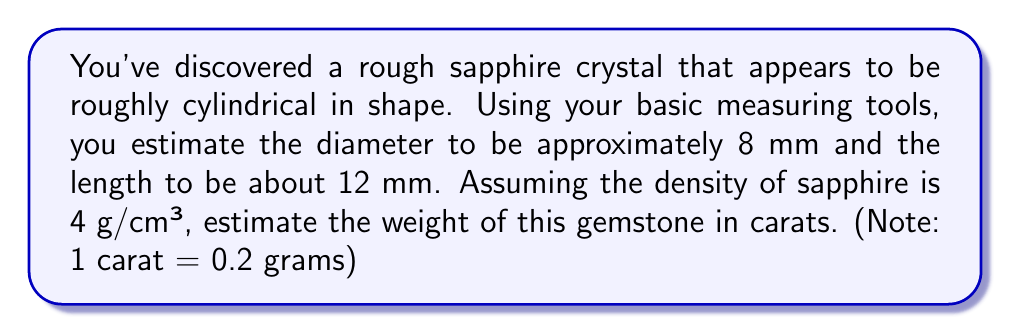Can you answer this question? Let's approach this step-by-step:

1) First, we need to calculate the volume of the cylindrical sapphire.
   The formula for the volume of a cylinder is:
   $$V = \pi r^2 h$$
   where $r$ is the radius and $h$ is the height (length) of the cylinder.

2) We're given the diameter (8 mm), so we need to halve this to get the radius:
   $$r = 8 \text{ mm} \div 2 = 4 \text{ mm} = 0.4 \text{ cm}$$

3) Now we can calculate the volume:
   $$V = \pi (0.4 \text{ cm})^2 (1.2 \text{ cm}) = 0.6032\pi \text{ cm}^3 \approx 1.8947 \text{ cm}^3$$

4) Given the density of sapphire (4 g/cm³), we can calculate the mass:
   $$\text{mass} = \text{density} \times \text{volume}$$
   $$\text{mass} = 4 \text{ g/cm}^3 \times 1.8947 \text{ cm}^3 = 7.5788 \text{ g}$$

5) Finally, we need to convert grams to carats:
   $$7.5788 \text{ g} \times \frac{1 \text{ carat}}{0.2 \text{ g}} = 37.894 \text{ carats}$$

6) Rounding to a reasonable precision for an estimate, we get 37.9 carats.
Answer: 37.9 carats 